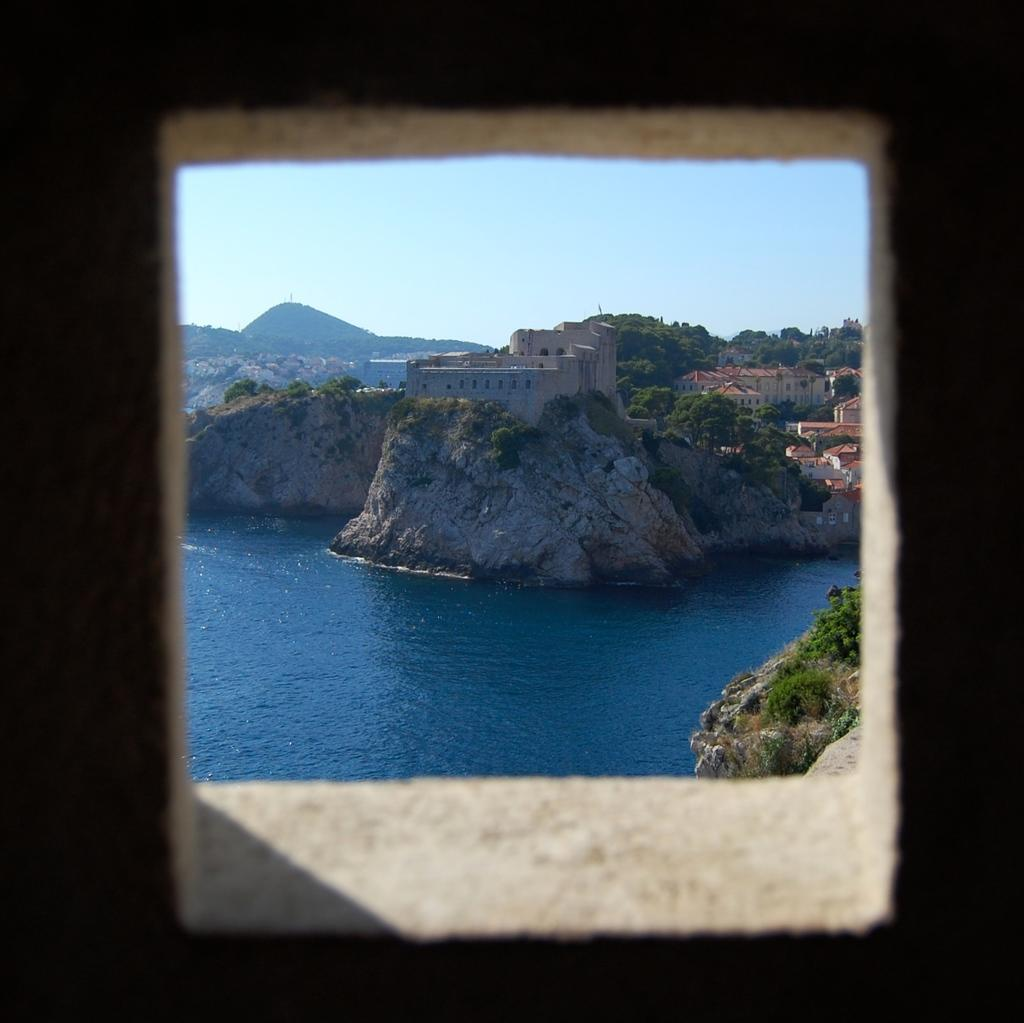What is the main object in the image? There is an object in the image, but the specific details are not provided. What can be seen in the background of the image? In the background of the image, there is water, buildings, trees, plants, mountains, and the sky. How many different types of natural elements are visible in the background? There are four different types of natural elements visible in the background: water, trees, plants, and mountains. What type of knife is being used by the representative in the image? There is no representative or knife present in the image. How many people are visible in the image? The number of people visible in the image is not mentioned in the provided facts. 